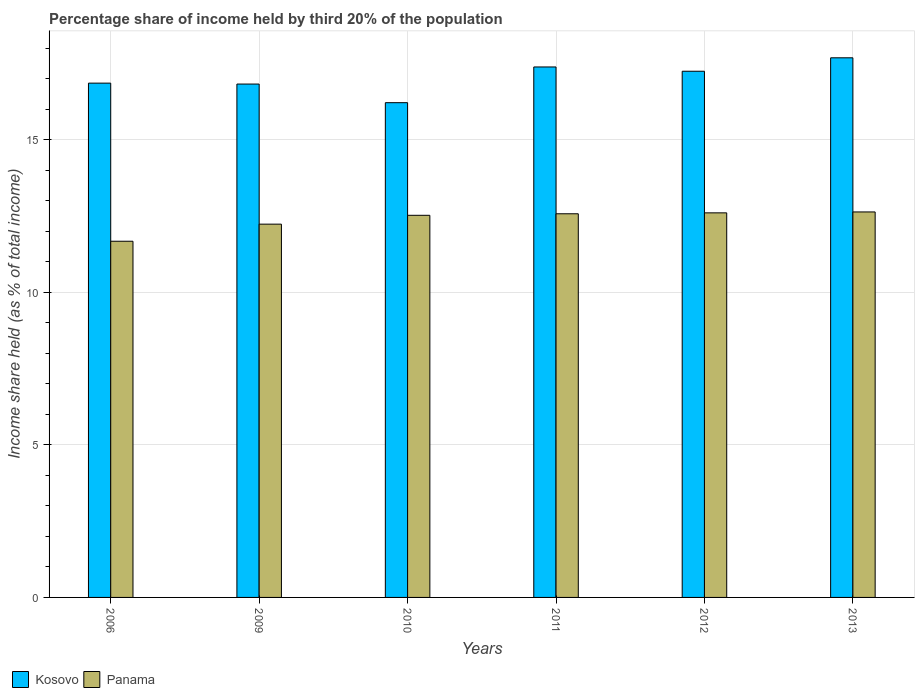How many different coloured bars are there?
Ensure brevity in your answer.  2. How many groups of bars are there?
Your response must be concise. 6. Are the number of bars per tick equal to the number of legend labels?
Give a very brief answer. Yes. Are the number of bars on each tick of the X-axis equal?
Give a very brief answer. Yes. How many bars are there on the 5th tick from the left?
Your answer should be compact. 2. What is the label of the 1st group of bars from the left?
Your answer should be very brief. 2006. In how many cases, is the number of bars for a given year not equal to the number of legend labels?
Keep it short and to the point. 0. What is the share of income held by third 20% of the population in Kosovo in 2011?
Your answer should be very brief. 17.38. Across all years, what is the maximum share of income held by third 20% of the population in Panama?
Offer a very short reply. 12.63. Across all years, what is the minimum share of income held by third 20% of the population in Panama?
Provide a succinct answer. 11.67. In which year was the share of income held by third 20% of the population in Panama maximum?
Offer a terse response. 2013. In which year was the share of income held by third 20% of the population in Kosovo minimum?
Your answer should be very brief. 2010. What is the total share of income held by third 20% of the population in Panama in the graph?
Make the answer very short. 74.22. What is the difference between the share of income held by third 20% of the population in Panama in 2010 and that in 2011?
Offer a terse response. -0.05. What is the difference between the share of income held by third 20% of the population in Kosovo in 2006 and the share of income held by third 20% of the population in Panama in 2013?
Ensure brevity in your answer.  4.22. What is the average share of income held by third 20% of the population in Panama per year?
Keep it short and to the point. 12.37. In the year 2006, what is the difference between the share of income held by third 20% of the population in Kosovo and share of income held by third 20% of the population in Panama?
Make the answer very short. 5.18. In how many years, is the share of income held by third 20% of the population in Panama greater than 5 %?
Keep it short and to the point. 6. What is the ratio of the share of income held by third 20% of the population in Kosovo in 2009 to that in 2010?
Provide a succinct answer. 1.04. Is the difference between the share of income held by third 20% of the population in Kosovo in 2009 and 2011 greater than the difference between the share of income held by third 20% of the population in Panama in 2009 and 2011?
Keep it short and to the point. No. What is the difference between the highest and the second highest share of income held by third 20% of the population in Panama?
Offer a very short reply. 0.03. What is the difference between the highest and the lowest share of income held by third 20% of the population in Panama?
Make the answer very short. 0.96. In how many years, is the share of income held by third 20% of the population in Panama greater than the average share of income held by third 20% of the population in Panama taken over all years?
Your answer should be very brief. 4. Is the sum of the share of income held by third 20% of the population in Panama in 2010 and 2013 greater than the maximum share of income held by third 20% of the population in Kosovo across all years?
Provide a short and direct response. Yes. What does the 1st bar from the left in 2010 represents?
Keep it short and to the point. Kosovo. What does the 1st bar from the right in 2009 represents?
Your answer should be compact. Panama. How many bars are there?
Your response must be concise. 12. How many years are there in the graph?
Provide a succinct answer. 6. Are the values on the major ticks of Y-axis written in scientific E-notation?
Your response must be concise. No. Does the graph contain any zero values?
Provide a succinct answer. No. Does the graph contain grids?
Your answer should be compact. Yes. Where does the legend appear in the graph?
Your answer should be compact. Bottom left. How many legend labels are there?
Offer a terse response. 2. What is the title of the graph?
Offer a terse response. Percentage share of income held by third 20% of the population. What is the label or title of the Y-axis?
Your answer should be very brief. Income share held (as % of total income). What is the Income share held (as % of total income) in Kosovo in 2006?
Keep it short and to the point. 16.85. What is the Income share held (as % of total income) in Panama in 2006?
Provide a short and direct response. 11.67. What is the Income share held (as % of total income) of Kosovo in 2009?
Your answer should be compact. 16.82. What is the Income share held (as % of total income) in Panama in 2009?
Offer a terse response. 12.23. What is the Income share held (as % of total income) in Kosovo in 2010?
Your answer should be compact. 16.21. What is the Income share held (as % of total income) of Panama in 2010?
Ensure brevity in your answer.  12.52. What is the Income share held (as % of total income) of Kosovo in 2011?
Offer a very short reply. 17.38. What is the Income share held (as % of total income) of Panama in 2011?
Your answer should be very brief. 12.57. What is the Income share held (as % of total income) in Kosovo in 2012?
Give a very brief answer. 17.24. What is the Income share held (as % of total income) of Panama in 2012?
Your answer should be compact. 12.6. What is the Income share held (as % of total income) of Kosovo in 2013?
Give a very brief answer. 17.68. What is the Income share held (as % of total income) of Panama in 2013?
Provide a succinct answer. 12.63. Across all years, what is the maximum Income share held (as % of total income) of Kosovo?
Offer a very short reply. 17.68. Across all years, what is the maximum Income share held (as % of total income) of Panama?
Offer a very short reply. 12.63. Across all years, what is the minimum Income share held (as % of total income) of Kosovo?
Ensure brevity in your answer.  16.21. Across all years, what is the minimum Income share held (as % of total income) in Panama?
Offer a terse response. 11.67. What is the total Income share held (as % of total income) of Kosovo in the graph?
Your response must be concise. 102.18. What is the total Income share held (as % of total income) of Panama in the graph?
Your answer should be compact. 74.22. What is the difference between the Income share held (as % of total income) in Kosovo in 2006 and that in 2009?
Make the answer very short. 0.03. What is the difference between the Income share held (as % of total income) of Panama in 2006 and that in 2009?
Your answer should be compact. -0.56. What is the difference between the Income share held (as % of total income) of Kosovo in 2006 and that in 2010?
Ensure brevity in your answer.  0.64. What is the difference between the Income share held (as % of total income) of Panama in 2006 and that in 2010?
Provide a short and direct response. -0.85. What is the difference between the Income share held (as % of total income) of Kosovo in 2006 and that in 2011?
Keep it short and to the point. -0.53. What is the difference between the Income share held (as % of total income) in Panama in 2006 and that in 2011?
Offer a very short reply. -0.9. What is the difference between the Income share held (as % of total income) in Kosovo in 2006 and that in 2012?
Provide a succinct answer. -0.39. What is the difference between the Income share held (as % of total income) in Panama in 2006 and that in 2012?
Offer a terse response. -0.93. What is the difference between the Income share held (as % of total income) of Kosovo in 2006 and that in 2013?
Your response must be concise. -0.83. What is the difference between the Income share held (as % of total income) of Panama in 2006 and that in 2013?
Offer a very short reply. -0.96. What is the difference between the Income share held (as % of total income) of Kosovo in 2009 and that in 2010?
Your answer should be very brief. 0.61. What is the difference between the Income share held (as % of total income) in Panama in 2009 and that in 2010?
Provide a succinct answer. -0.29. What is the difference between the Income share held (as % of total income) of Kosovo in 2009 and that in 2011?
Offer a very short reply. -0.56. What is the difference between the Income share held (as % of total income) in Panama in 2009 and that in 2011?
Your answer should be very brief. -0.34. What is the difference between the Income share held (as % of total income) of Kosovo in 2009 and that in 2012?
Offer a terse response. -0.42. What is the difference between the Income share held (as % of total income) of Panama in 2009 and that in 2012?
Provide a short and direct response. -0.37. What is the difference between the Income share held (as % of total income) in Kosovo in 2009 and that in 2013?
Your answer should be compact. -0.86. What is the difference between the Income share held (as % of total income) of Kosovo in 2010 and that in 2011?
Keep it short and to the point. -1.17. What is the difference between the Income share held (as % of total income) of Kosovo in 2010 and that in 2012?
Offer a terse response. -1.03. What is the difference between the Income share held (as % of total income) in Panama in 2010 and that in 2012?
Your response must be concise. -0.08. What is the difference between the Income share held (as % of total income) in Kosovo in 2010 and that in 2013?
Ensure brevity in your answer.  -1.47. What is the difference between the Income share held (as % of total income) in Panama in 2010 and that in 2013?
Your answer should be compact. -0.11. What is the difference between the Income share held (as % of total income) of Kosovo in 2011 and that in 2012?
Offer a terse response. 0.14. What is the difference between the Income share held (as % of total income) of Panama in 2011 and that in 2012?
Make the answer very short. -0.03. What is the difference between the Income share held (as % of total income) in Kosovo in 2011 and that in 2013?
Make the answer very short. -0.3. What is the difference between the Income share held (as % of total income) of Panama in 2011 and that in 2013?
Keep it short and to the point. -0.06. What is the difference between the Income share held (as % of total income) of Kosovo in 2012 and that in 2013?
Make the answer very short. -0.44. What is the difference between the Income share held (as % of total income) of Panama in 2012 and that in 2013?
Provide a short and direct response. -0.03. What is the difference between the Income share held (as % of total income) in Kosovo in 2006 and the Income share held (as % of total income) in Panama in 2009?
Keep it short and to the point. 4.62. What is the difference between the Income share held (as % of total income) of Kosovo in 2006 and the Income share held (as % of total income) of Panama in 2010?
Your response must be concise. 4.33. What is the difference between the Income share held (as % of total income) in Kosovo in 2006 and the Income share held (as % of total income) in Panama in 2011?
Make the answer very short. 4.28. What is the difference between the Income share held (as % of total income) of Kosovo in 2006 and the Income share held (as % of total income) of Panama in 2012?
Offer a very short reply. 4.25. What is the difference between the Income share held (as % of total income) of Kosovo in 2006 and the Income share held (as % of total income) of Panama in 2013?
Keep it short and to the point. 4.22. What is the difference between the Income share held (as % of total income) of Kosovo in 2009 and the Income share held (as % of total income) of Panama in 2010?
Your answer should be compact. 4.3. What is the difference between the Income share held (as % of total income) in Kosovo in 2009 and the Income share held (as % of total income) in Panama in 2011?
Provide a short and direct response. 4.25. What is the difference between the Income share held (as % of total income) in Kosovo in 2009 and the Income share held (as % of total income) in Panama in 2012?
Provide a short and direct response. 4.22. What is the difference between the Income share held (as % of total income) in Kosovo in 2009 and the Income share held (as % of total income) in Panama in 2013?
Keep it short and to the point. 4.19. What is the difference between the Income share held (as % of total income) of Kosovo in 2010 and the Income share held (as % of total income) of Panama in 2011?
Make the answer very short. 3.64. What is the difference between the Income share held (as % of total income) of Kosovo in 2010 and the Income share held (as % of total income) of Panama in 2012?
Offer a very short reply. 3.61. What is the difference between the Income share held (as % of total income) of Kosovo in 2010 and the Income share held (as % of total income) of Panama in 2013?
Provide a succinct answer. 3.58. What is the difference between the Income share held (as % of total income) of Kosovo in 2011 and the Income share held (as % of total income) of Panama in 2012?
Ensure brevity in your answer.  4.78. What is the difference between the Income share held (as % of total income) in Kosovo in 2011 and the Income share held (as % of total income) in Panama in 2013?
Offer a very short reply. 4.75. What is the difference between the Income share held (as % of total income) in Kosovo in 2012 and the Income share held (as % of total income) in Panama in 2013?
Your answer should be very brief. 4.61. What is the average Income share held (as % of total income) in Kosovo per year?
Offer a very short reply. 17.03. What is the average Income share held (as % of total income) in Panama per year?
Provide a short and direct response. 12.37. In the year 2006, what is the difference between the Income share held (as % of total income) in Kosovo and Income share held (as % of total income) in Panama?
Ensure brevity in your answer.  5.18. In the year 2009, what is the difference between the Income share held (as % of total income) in Kosovo and Income share held (as % of total income) in Panama?
Offer a terse response. 4.59. In the year 2010, what is the difference between the Income share held (as % of total income) in Kosovo and Income share held (as % of total income) in Panama?
Make the answer very short. 3.69. In the year 2011, what is the difference between the Income share held (as % of total income) in Kosovo and Income share held (as % of total income) in Panama?
Give a very brief answer. 4.81. In the year 2012, what is the difference between the Income share held (as % of total income) in Kosovo and Income share held (as % of total income) in Panama?
Provide a succinct answer. 4.64. In the year 2013, what is the difference between the Income share held (as % of total income) in Kosovo and Income share held (as % of total income) in Panama?
Your answer should be compact. 5.05. What is the ratio of the Income share held (as % of total income) in Kosovo in 2006 to that in 2009?
Provide a succinct answer. 1. What is the ratio of the Income share held (as % of total income) in Panama in 2006 to that in 2009?
Offer a very short reply. 0.95. What is the ratio of the Income share held (as % of total income) of Kosovo in 2006 to that in 2010?
Give a very brief answer. 1.04. What is the ratio of the Income share held (as % of total income) of Panama in 2006 to that in 2010?
Keep it short and to the point. 0.93. What is the ratio of the Income share held (as % of total income) in Kosovo in 2006 to that in 2011?
Provide a short and direct response. 0.97. What is the ratio of the Income share held (as % of total income) in Panama in 2006 to that in 2011?
Provide a succinct answer. 0.93. What is the ratio of the Income share held (as % of total income) of Kosovo in 2006 to that in 2012?
Make the answer very short. 0.98. What is the ratio of the Income share held (as % of total income) of Panama in 2006 to that in 2012?
Offer a terse response. 0.93. What is the ratio of the Income share held (as % of total income) of Kosovo in 2006 to that in 2013?
Your response must be concise. 0.95. What is the ratio of the Income share held (as % of total income) of Panama in 2006 to that in 2013?
Ensure brevity in your answer.  0.92. What is the ratio of the Income share held (as % of total income) in Kosovo in 2009 to that in 2010?
Keep it short and to the point. 1.04. What is the ratio of the Income share held (as % of total income) of Panama in 2009 to that in 2010?
Provide a short and direct response. 0.98. What is the ratio of the Income share held (as % of total income) of Kosovo in 2009 to that in 2011?
Keep it short and to the point. 0.97. What is the ratio of the Income share held (as % of total income) in Kosovo in 2009 to that in 2012?
Make the answer very short. 0.98. What is the ratio of the Income share held (as % of total income) of Panama in 2009 to that in 2012?
Ensure brevity in your answer.  0.97. What is the ratio of the Income share held (as % of total income) of Kosovo in 2009 to that in 2013?
Keep it short and to the point. 0.95. What is the ratio of the Income share held (as % of total income) of Panama in 2009 to that in 2013?
Ensure brevity in your answer.  0.97. What is the ratio of the Income share held (as % of total income) in Kosovo in 2010 to that in 2011?
Your answer should be very brief. 0.93. What is the ratio of the Income share held (as % of total income) in Panama in 2010 to that in 2011?
Ensure brevity in your answer.  1. What is the ratio of the Income share held (as % of total income) in Kosovo in 2010 to that in 2012?
Make the answer very short. 0.94. What is the ratio of the Income share held (as % of total income) in Panama in 2010 to that in 2012?
Make the answer very short. 0.99. What is the ratio of the Income share held (as % of total income) in Kosovo in 2010 to that in 2013?
Give a very brief answer. 0.92. What is the ratio of the Income share held (as % of total income) of Panama in 2010 to that in 2013?
Your answer should be very brief. 0.99. What is the ratio of the Income share held (as % of total income) in Kosovo in 2011 to that in 2012?
Offer a terse response. 1.01. What is the ratio of the Income share held (as % of total income) of Panama in 2011 to that in 2013?
Offer a terse response. 1. What is the ratio of the Income share held (as % of total income) of Kosovo in 2012 to that in 2013?
Your answer should be compact. 0.98. What is the difference between the highest and the second highest Income share held (as % of total income) of Panama?
Ensure brevity in your answer.  0.03. What is the difference between the highest and the lowest Income share held (as % of total income) of Kosovo?
Make the answer very short. 1.47. 